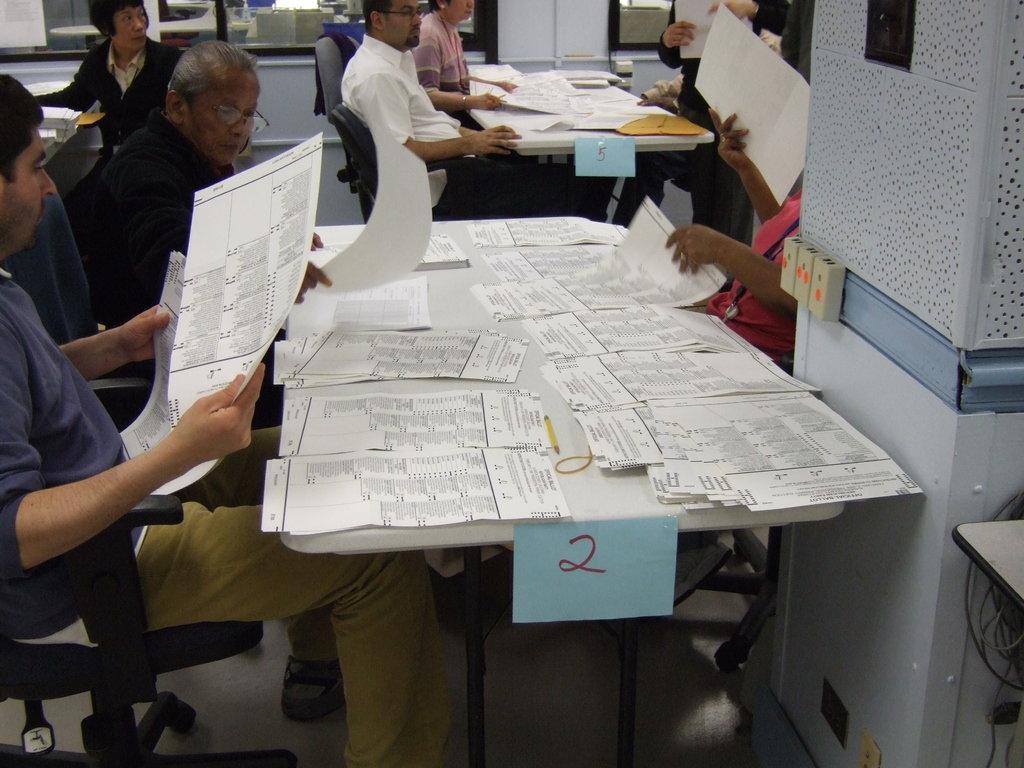Please provide a concise description of this image. In the image we can see few persons were sitting on the chair around the table. On table we can see papers,and few more objects around them. 